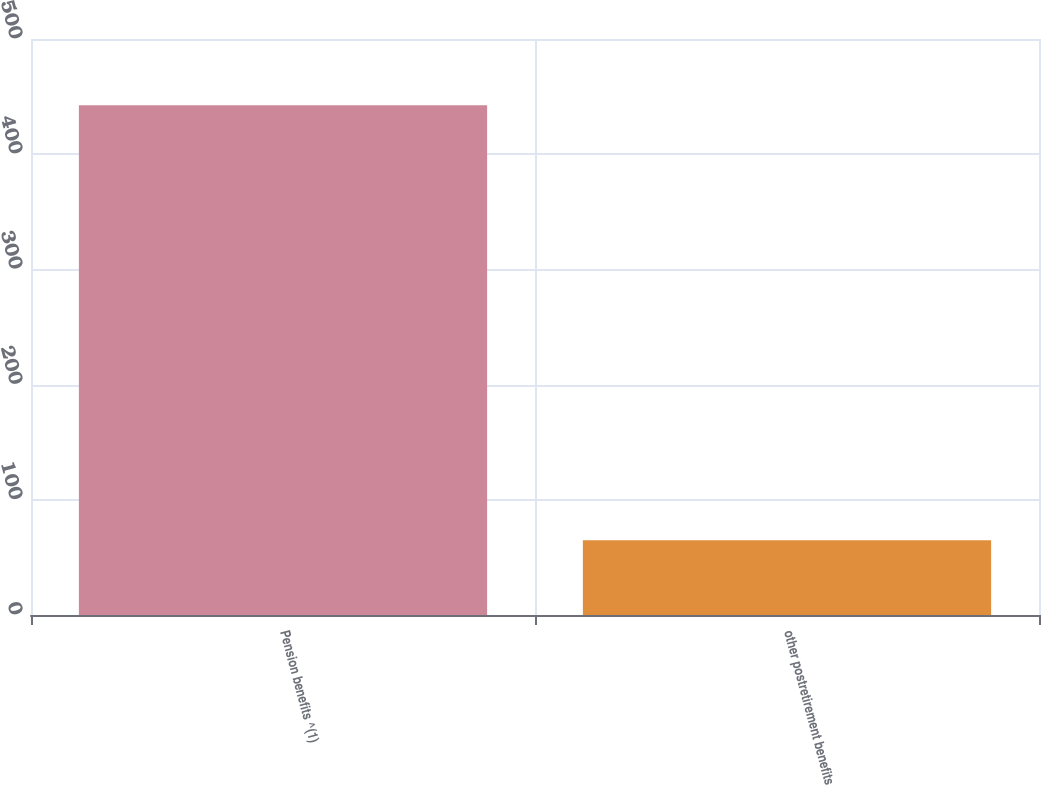Convert chart to OTSL. <chart><loc_0><loc_0><loc_500><loc_500><bar_chart><fcel>Pension benefits ^(1)<fcel>other postretirement benefits<nl><fcel>442.5<fcel>64.9<nl></chart> 